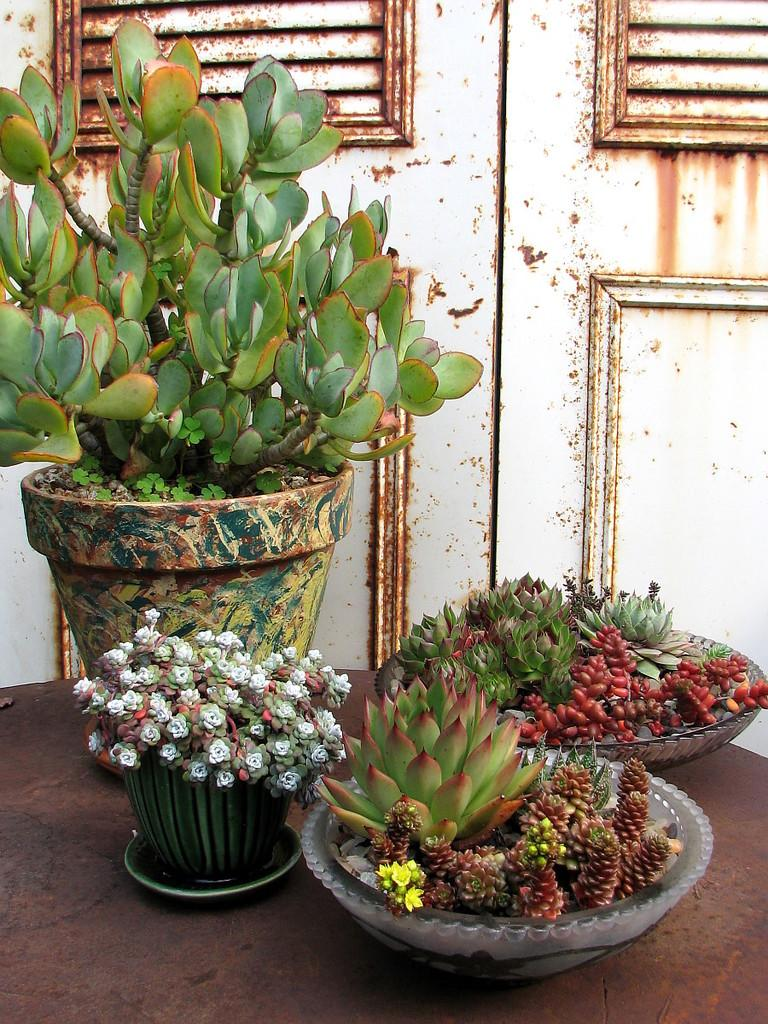What types of plants can be seen in the image? There are different kinds of plants in the image. How are the plants arranged or displayed in the image? The plants are in flower pots. What can be seen in the background of the image? There is a rusted door in the background of the image. Can you tell me how many yaks are visible in the image? There are no yaks present in the image; it features different kinds of plants in flower pots and a rusted door in the background. 